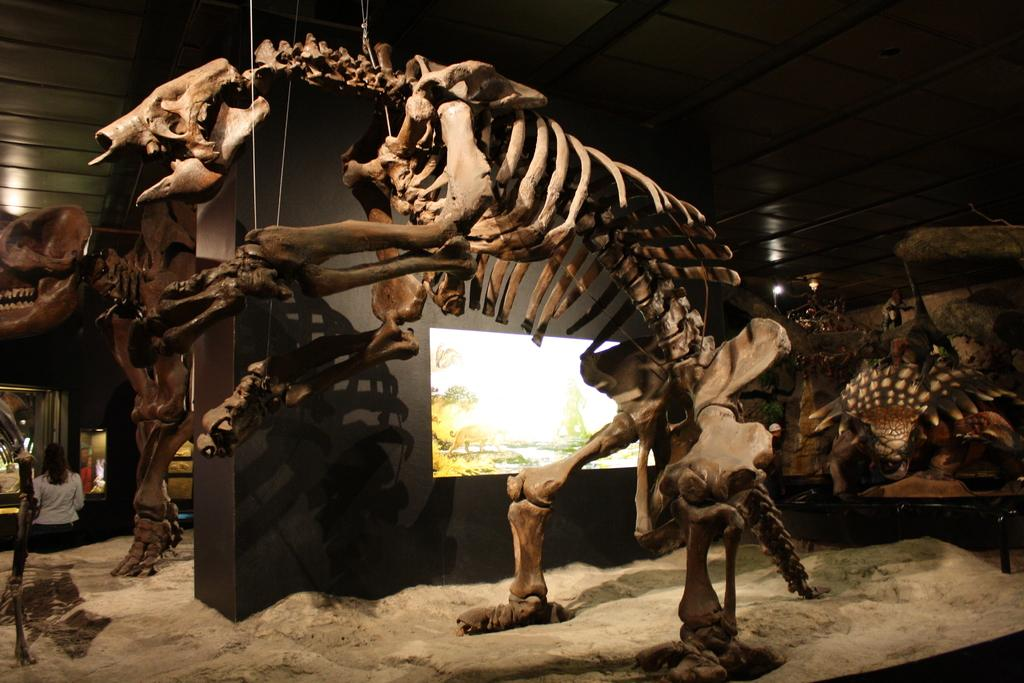What is the main subject in the center of the image? There is a skeleton in the center of the image. What can be seen in the background of the image? There is a wall and a window in the background of the image. Are there any other subjects or objects on the left side of the image? Yes, there is a skeleton and a woman on the left side of the image. What type of harbor can be seen in the image? There is no harbor present in the image. What achievements has the middle skeleton accomplished in the image? There is no skeleton in the middle of the image, and achievements cannot be attributed to a skeleton. 